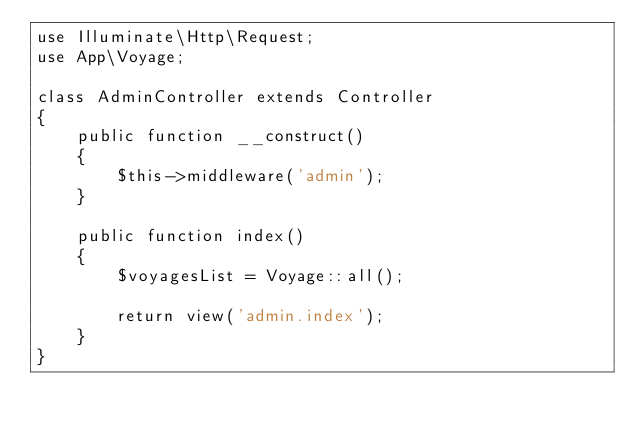Convert code to text. <code><loc_0><loc_0><loc_500><loc_500><_PHP_>use Illuminate\Http\Request;
use App\Voyage;

class AdminController extends Controller
{
    public function __construct()
    {
        $this->middleware('admin');
    }

    public function index()
    {
        $voyagesList = Voyage::all();

        return view('admin.index');
    }
}
</code> 